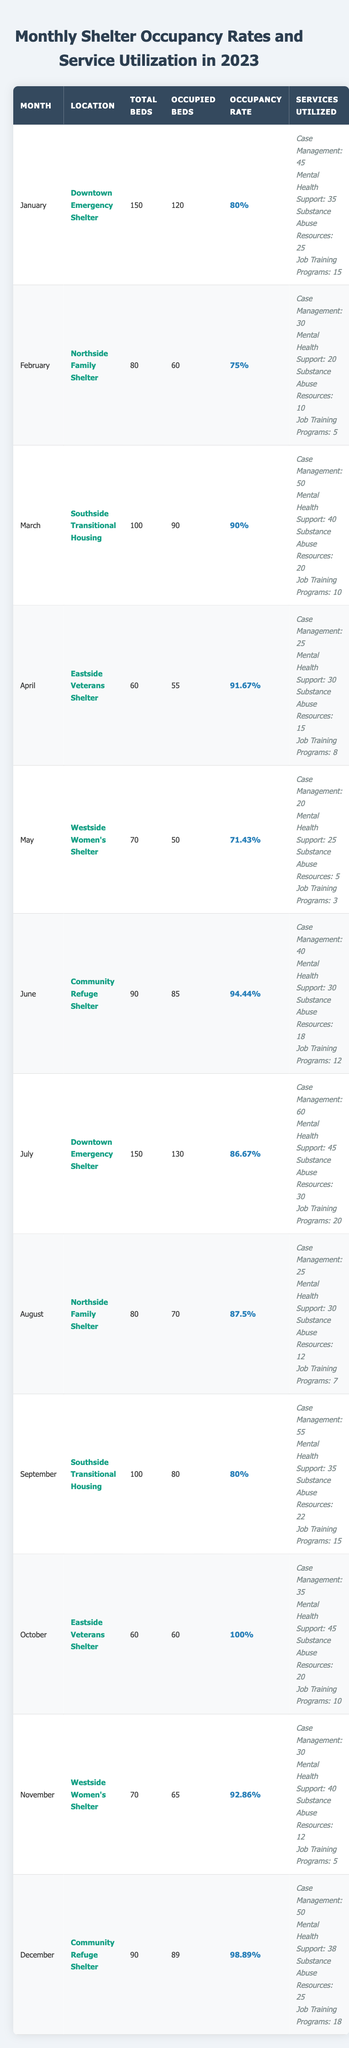What was the occupancy rate for the Community Refuge Shelter in June? The occupancy rate for the Community Refuge Shelter in June is listed in the table as 94.44%.
Answer: 94.44% Which month had the highest occupancy rate and what was it? The highest occupancy rate is found in October, with a rate of 100% at the Eastside Veterans Shelter.
Answer: 100% in October What percentage of beds were occupied at the Northside Family Shelter in February? The table shows that in February, 60 out of 80 beds were occupied, resulting in an occupancy rate of 75%.
Answer: 75% How many total beds were available across all shelters in December? In December, the total number of beds is 90 for the Community Refuge Shelter, which is the only entry for that month in the table.
Answer: 90 Did the Downtown Emergency Shelter in January have more or fewer occupied beds than the Westside Women’s Shelter in May? The Downtown Emergency Shelter had 120 occupied beds in January, while the Westside Women's Shelter had 50 occupied beds in May, indicating more occupied beds in January.
Answer: More occupied beds in January What is the average occupancy rate of the shelters for the months of January to June? To find the average, sum the occupancy rates for those months: (80 + 75 + 90 + 91.67 + 71.43 + 94.44) = 502.54. Dividing by 6 gives an average of 83.76%.
Answer: 83.76% How many services were utilized for job training programs at the Southside Transitional Housing in March? The table indicates that in March, the Southside Transitional Housing utilized 10 job training programs.
Answer: 10 Which shelter had the lowest reported use of substance abuse resources in May, and how many were reported? The Westside Women’s Shelter in May had the lowest reported use of substance abuse resources, at 5.
Answer: 5 What were the total services utilized at the Eastside Veterans Shelter in April? The total services utilized in April are calculated as follows: Case Management (25) + Mental Health Support (30) + Substance Abuse Resources (15) + Job Training Programs (8) = 78.
Answer: 78 Was the occupancy rate at the Community Refuge Shelter in December higher than that of the Downtown Emergency Shelter in January? The Community Refuge Shelter had an occupancy rate of 98.89% in December, while the Downtown Emergency Shelter had 80% in January, making December's rate higher.
Answer: Yes, it was higher What is the difference in occupancy rates between the March rate and the February rate? The March occupancy rate was 90%, and the February rate was 75%. The difference is 90% - 75% = 15%.
Answer: 15% difference 